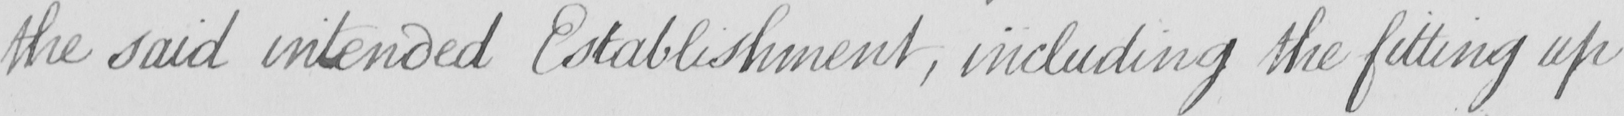What does this handwritten line say? the said intended Establishment  , including the fitting up 